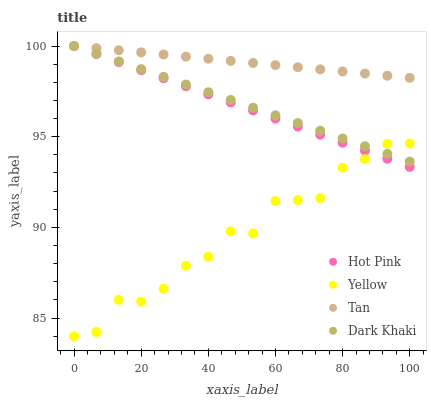Does Yellow have the minimum area under the curve?
Answer yes or no. Yes. Does Tan have the maximum area under the curve?
Answer yes or no. Yes. Does Hot Pink have the minimum area under the curve?
Answer yes or no. No. Does Hot Pink have the maximum area under the curve?
Answer yes or no. No. Is Tan the smoothest?
Answer yes or no. Yes. Is Yellow the roughest?
Answer yes or no. Yes. Is Hot Pink the smoothest?
Answer yes or no. No. Is Hot Pink the roughest?
Answer yes or no. No. Does Yellow have the lowest value?
Answer yes or no. Yes. Does Hot Pink have the lowest value?
Answer yes or no. No. Does Hot Pink have the highest value?
Answer yes or no. Yes. Does Yellow have the highest value?
Answer yes or no. No. Is Yellow less than Tan?
Answer yes or no. Yes. Is Tan greater than Yellow?
Answer yes or no. Yes. Does Dark Khaki intersect Tan?
Answer yes or no. Yes. Is Dark Khaki less than Tan?
Answer yes or no. No. Is Dark Khaki greater than Tan?
Answer yes or no. No. Does Yellow intersect Tan?
Answer yes or no. No. 